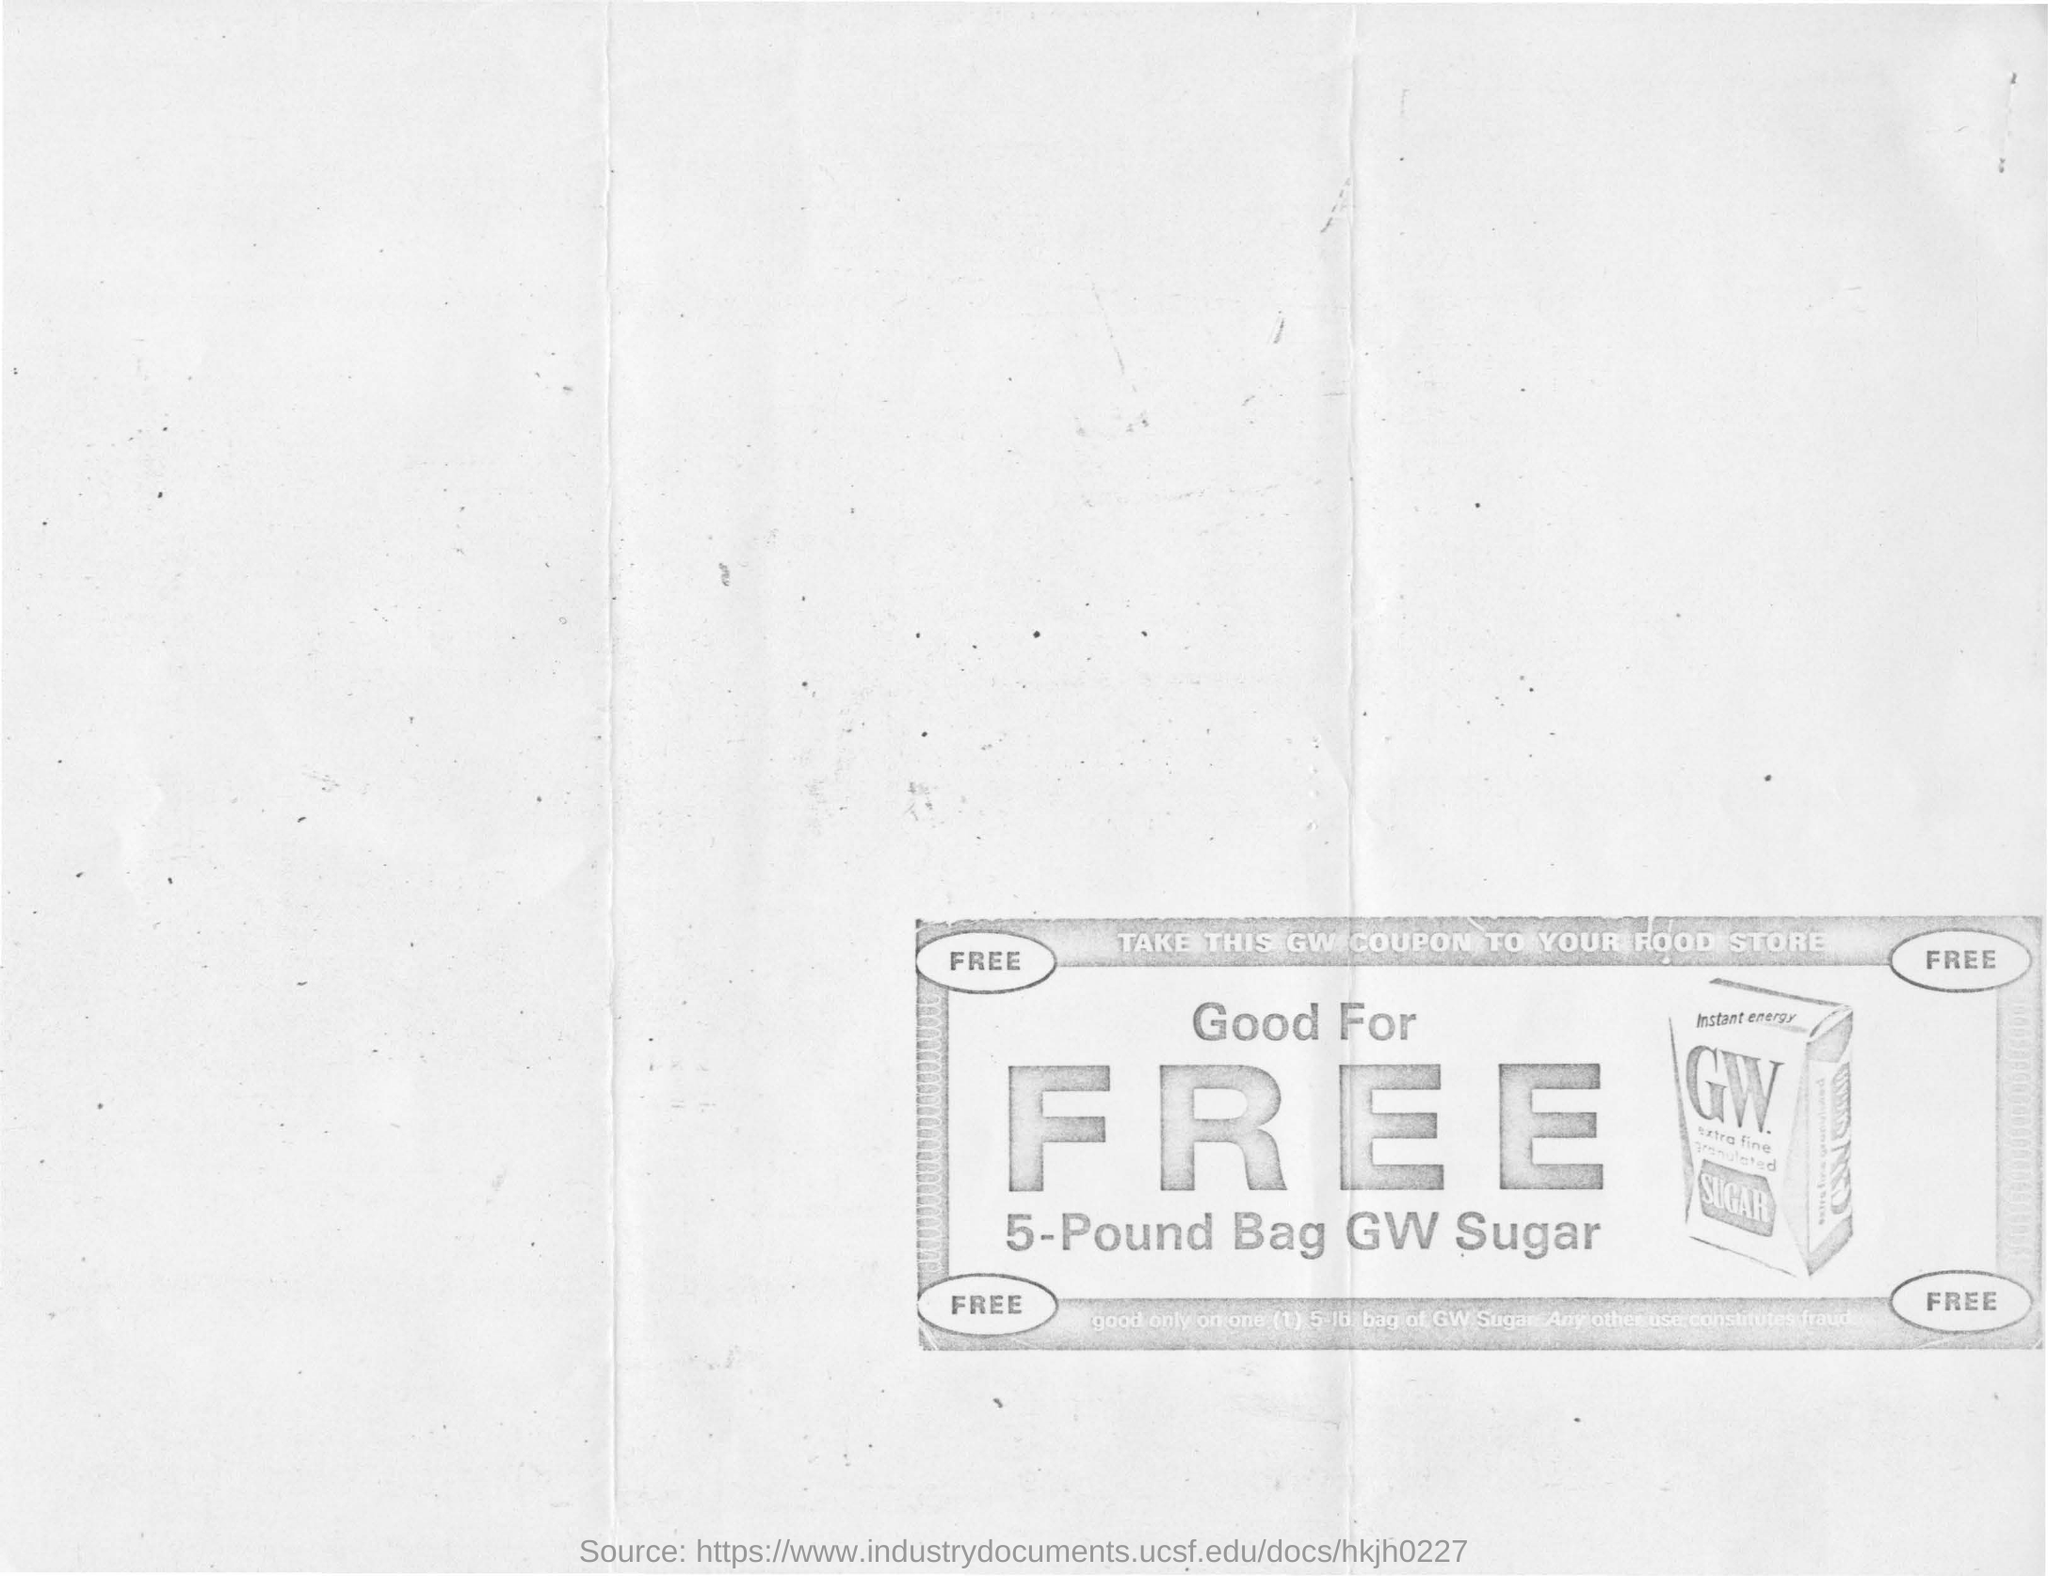Indicate a few pertinent items in this graphic. The message written on the top of the coupon reads 'TAKE THIS GW COUPON TO YOUR FOOD STORE.' The amount of sugar being given for free in a 5-pound bag is unknown. The name of the company is GW Sugar. 